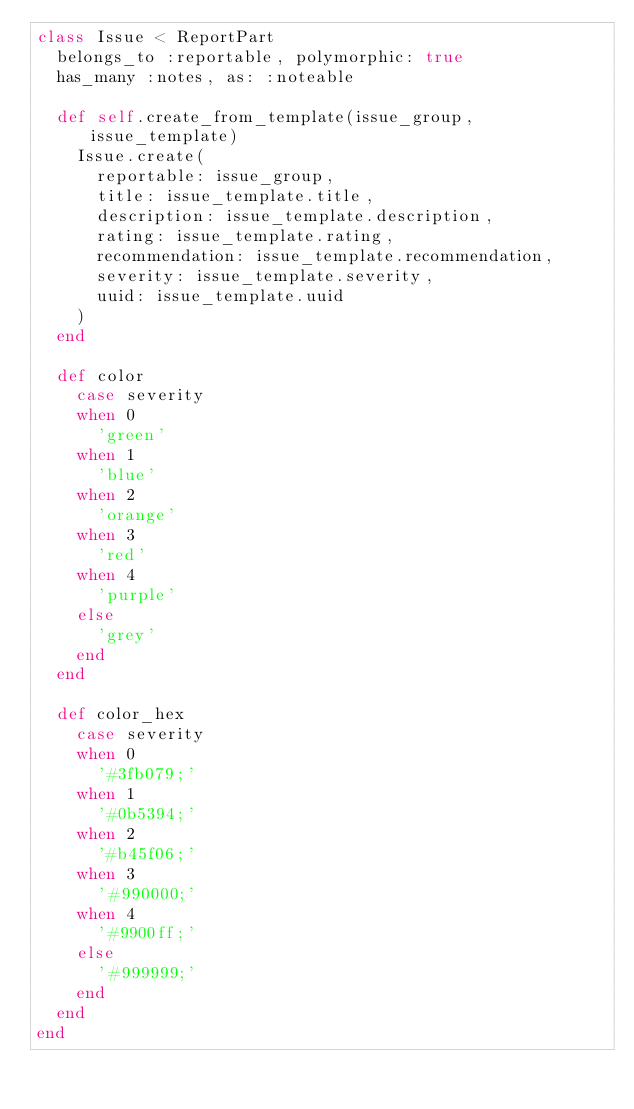<code> <loc_0><loc_0><loc_500><loc_500><_Ruby_>class Issue < ReportPart
  belongs_to :reportable, polymorphic: true
  has_many :notes, as: :noteable
  
  def self.create_from_template(issue_group, issue_template)
    Issue.create(
      reportable: issue_group,
      title: issue_template.title,
      description: issue_template.description,
      rating: issue_template.rating,
      recommendation: issue_template.recommendation,
      severity: issue_template.severity,
      uuid: issue_template.uuid
    )
  end

  def color
    case severity
    when 0
      'green'
    when 1
      'blue'
    when 2
      'orange'
    when 3
      'red'
    when 4
      'purple'
    else
      'grey'
    end
  end

  def color_hex
    case severity
    when 0
      '#3fb079;'
    when 1
      '#0b5394;'
    when 2
      '#b45f06;'
    when 3
      '#990000;'
    when 4
      '#9900ff;'
    else
      '#999999;'
    end
  end
end
</code> 